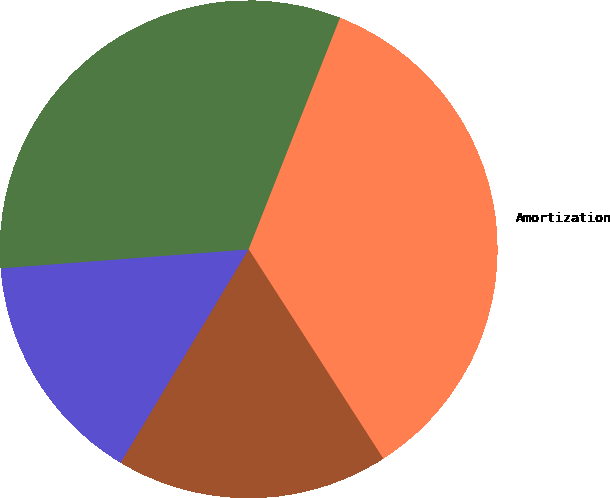Convert chart to OTSL. <chart><loc_0><loc_0><loc_500><loc_500><pie_chart><fcel>Selling general and<fcel>Research and development<fcel>Amortization<fcel>Total operating expenses<nl><fcel>15.19%<fcel>32.2%<fcel>34.92%<fcel>17.69%<nl></chart> 